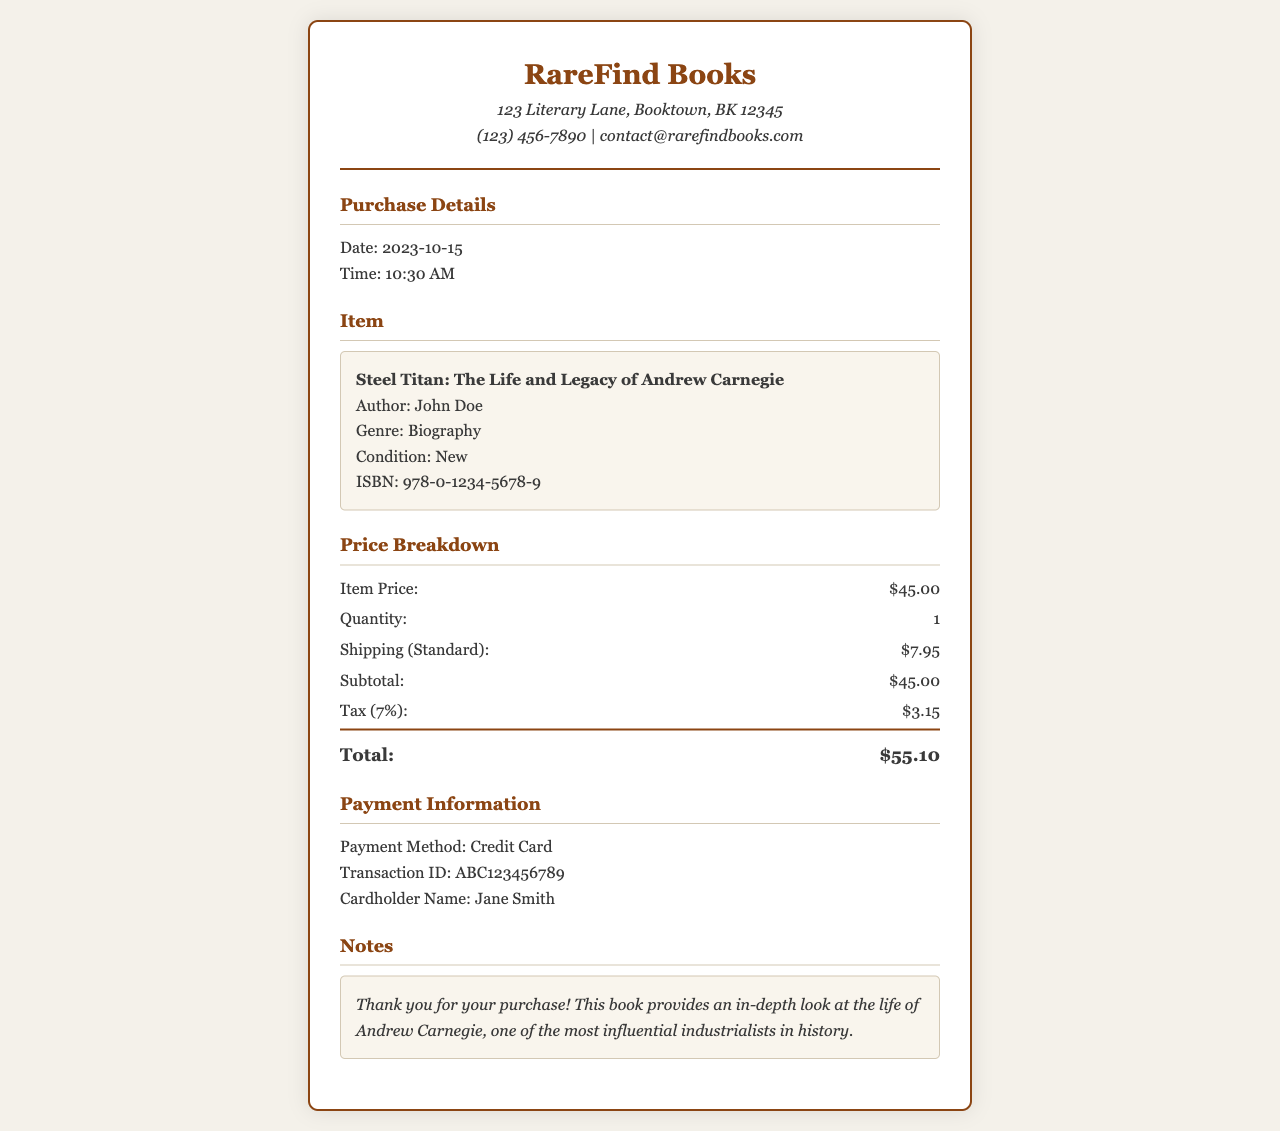What is the title of the book? The title of the book is stated clearly in the item details section.
Answer: Steel Titan: The Life and Legacy of Andrew Carnegie Who is the author of the biography? The author is mentioned below the book title in the item details.
Answer: John Doe What is the shipping cost? The shipping cost is detailed in the price breakdown section of the receipt.
Answer: $7.95 What is the tax amount applied to the purchase? The tax amount is explicitly stated in the price breakdown section.
Answer: $3.15 What is the transaction ID for the purchase? The transaction ID is listed under the payment information section.
Answer: ABC123456789 How much did the book cost before tax? The item price shows the cost of the book before tax in the receipt.
Answer: $45.00 What was the total amount paid for the purchase? The total is calculated and presented in the price breakdown of the receipt.
Answer: $55.10 What payment method was used for the transaction? The payment method is specified in the payment information section.
Answer: Credit Card What date was the purchase made? The date of purchase is provided in the purchase details section of the document.
Answer: 2023-10-15 